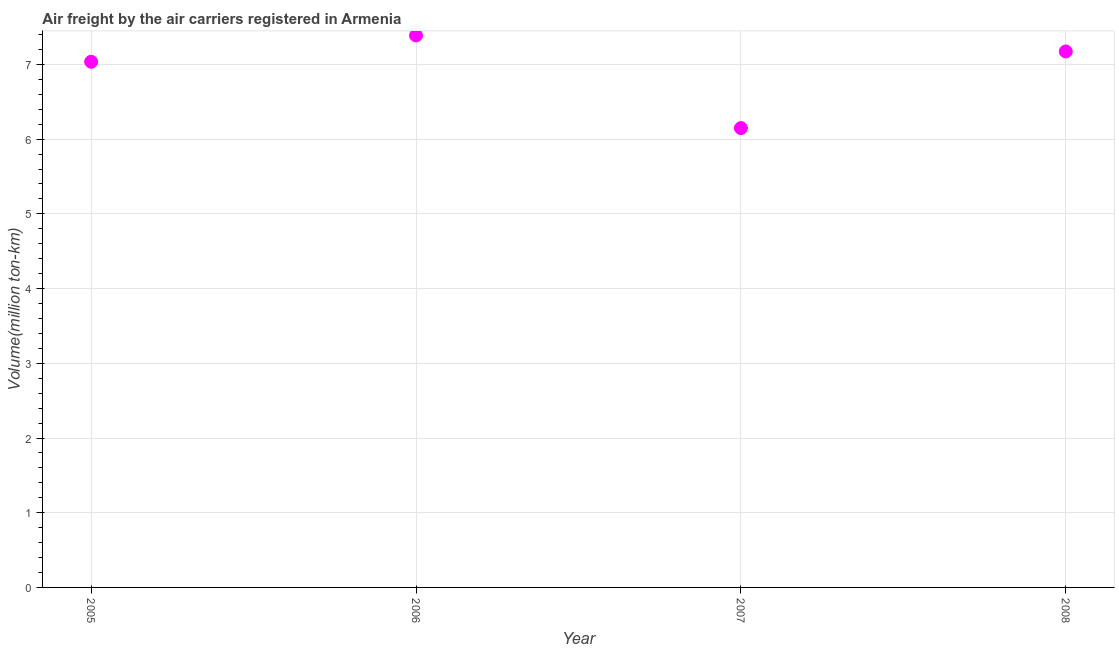What is the air freight in 2007?
Your answer should be very brief. 6.15. Across all years, what is the maximum air freight?
Provide a short and direct response. 7.39. Across all years, what is the minimum air freight?
Provide a short and direct response. 6.15. In which year was the air freight maximum?
Ensure brevity in your answer.  2006. What is the sum of the air freight?
Offer a terse response. 27.75. What is the difference between the air freight in 2005 and 2006?
Provide a succinct answer. -0.35. What is the average air freight per year?
Provide a succinct answer. 6.94. What is the median air freight?
Your answer should be compact. 7.11. Do a majority of the years between 2005 and 2006 (inclusive) have air freight greater than 2.8 million ton-km?
Give a very brief answer. Yes. What is the ratio of the air freight in 2006 to that in 2008?
Give a very brief answer. 1.03. Is the air freight in 2005 less than that in 2007?
Provide a short and direct response. No. What is the difference between the highest and the second highest air freight?
Your response must be concise. 0.21. Is the sum of the air freight in 2005 and 2007 greater than the maximum air freight across all years?
Give a very brief answer. Yes. What is the difference between the highest and the lowest air freight?
Provide a short and direct response. 1.24. In how many years, is the air freight greater than the average air freight taken over all years?
Make the answer very short. 3. What is the difference between two consecutive major ticks on the Y-axis?
Your answer should be very brief. 1. Does the graph contain grids?
Offer a very short reply. Yes. What is the title of the graph?
Offer a terse response. Air freight by the air carriers registered in Armenia. What is the label or title of the Y-axis?
Your answer should be compact. Volume(million ton-km). What is the Volume(million ton-km) in 2005?
Provide a short and direct response. 7.04. What is the Volume(million ton-km) in 2006?
Your answer should be compact. 7.39. What is the Volume(million ton-km) in 2007?
Your answer should be very brief. 6.15. What is the Volume(million ton-km) in 2008?
Your answer should be very brief. 7.17. What is the difference between the Volume(million ton-km) in 2005 and 2006?
Keep it short and to the point. -0.35. What is the difference between the Volume(million ton-km) in 2005 and 2007?
Offer a terse response. 0.89. What is the difference between the Volume(million ton-km) in 2005 and 2008?
Your answer should be very brief. -0.14. What is the difference between the Volume(million ton-km) in 2006 and 2007?
Make the answer very short. 1.24. What is the difference between the Volume(million ton-km) in 2006 and 2008?
Your response must be concise. 0.21. What is the difference between the Volume(million ton-km) in 2007 and 2008?
Provide a short and direct response. -1.03. What is the ratio of the Volume(million ton-km) in 2005 to that in 2007?
Your answer should be compact. 1.14. What is the ratio of the Volume(million ton-km) in 2005 to that in 2008?
Make the answer very short. 0.98. What is the ratio of the Volume(million ton-km) in 2006 to that in 2007?
Your response must be concise. 1.2. What is the ratio of the Volume(million ton-km) in 2006 to that in 2008?
Offer a very short reply. 1.03. What is the ratio of the Volume(million ton-km) in 2007 to that in 2008?
Your answer should be compact. 0.86. 